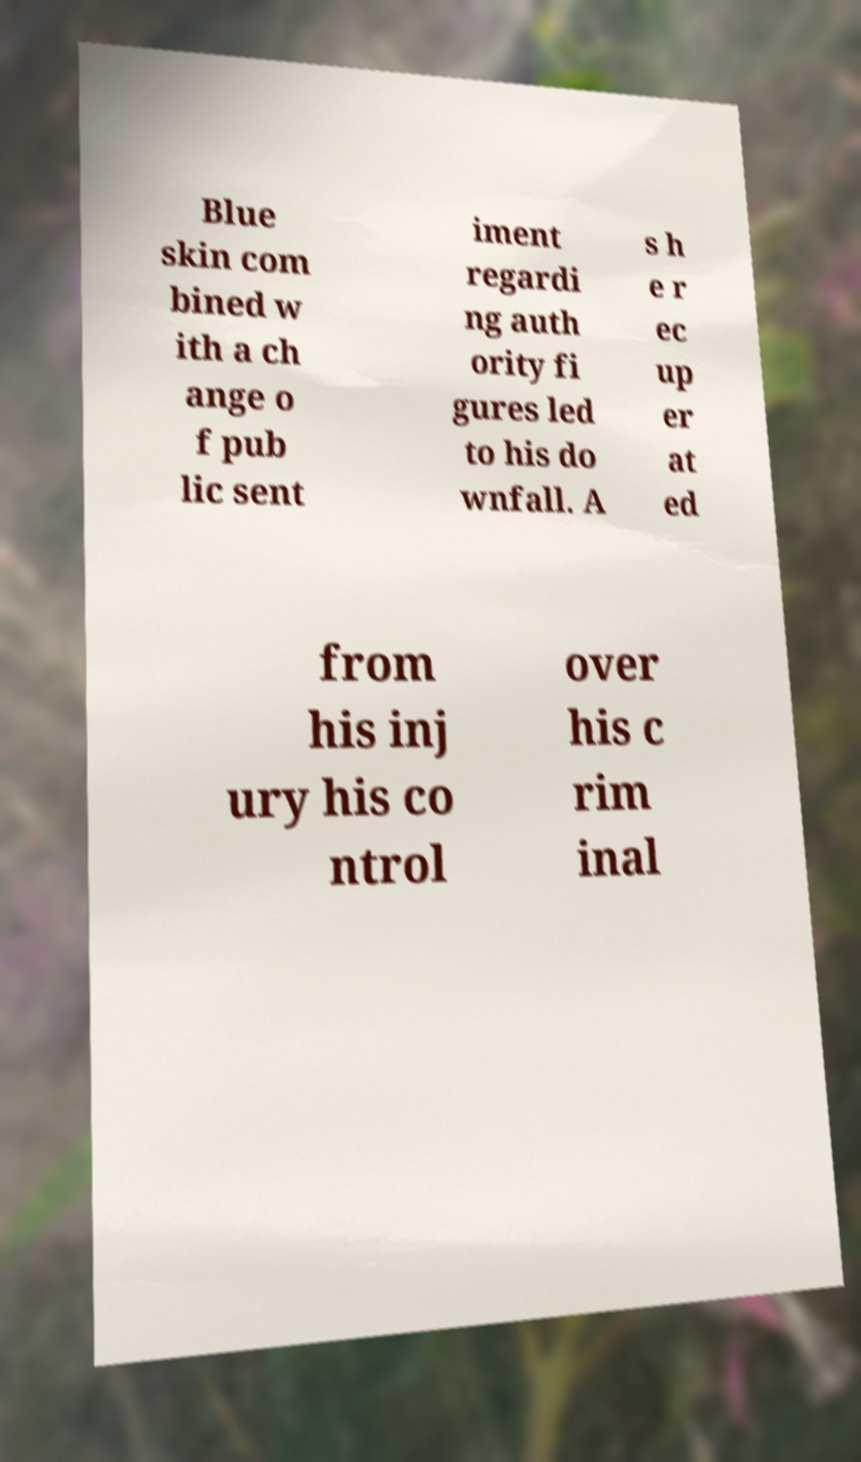I need the written content from this picture converted into text. Can you do that? Blue skin com bined w ith a ch ange o f pub lic sent iment regardi ng auth ority fi gures led to his do wnfall. A s h e r ec up er at ed from his inj ury his co ntrol over his c rim inal 